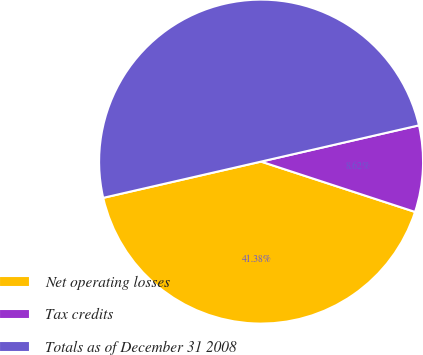Convert chart. <chart><loc_0><loc_0><loc_500><loc_500><pie_chart><fcel>Net operating losses<fcel>Tax credits<fcel>Totals as of December 31 2008<nl><fcel>41.38%<fcel>8.62%<fcel>50.0%<nl></chart> 